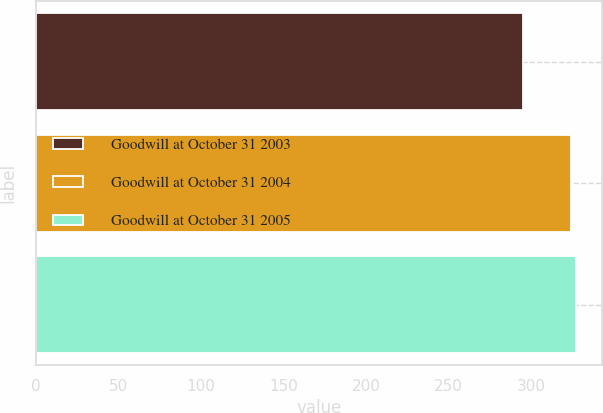Convert chart. <chart><loc_0><loc_0><loc_500><loc_500><bar_chart><fcel>Goodwill at October 31 2003<fcel>Goodwill at October 31 2004<fcel>Goodwill at October 31 2005<nl><fcel>295<fcel>324<fcel>326.9<nl></chart> 